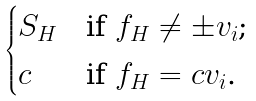Convert formula to latex. <formula><loc_0><loc_0><loc_500><loc_500>\begin{cases} S _ { H } & \text {if $f_{H}\neq \pm v_{i}$;} \\ c & \text {if $f_{H}=c v_{i}$.} \end{cases}</formula> 